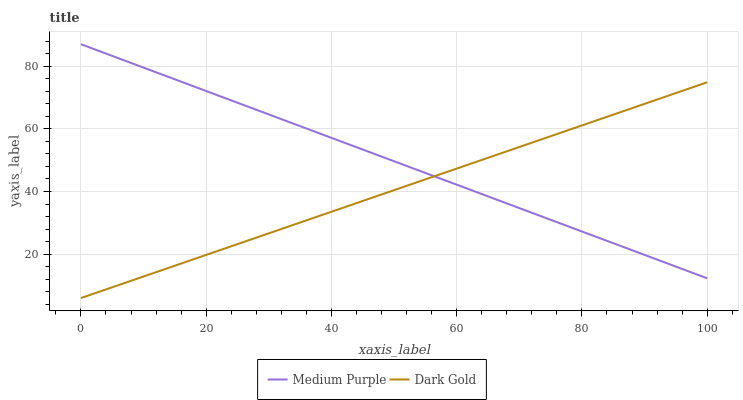Does Dark Gold have the maximum area under the curve?
Answer yes or no. No. Is Dark Gold the roughest?
Answer yes or no. No. Does Dark Gold have the highest value?
Answer yes or no. No. 